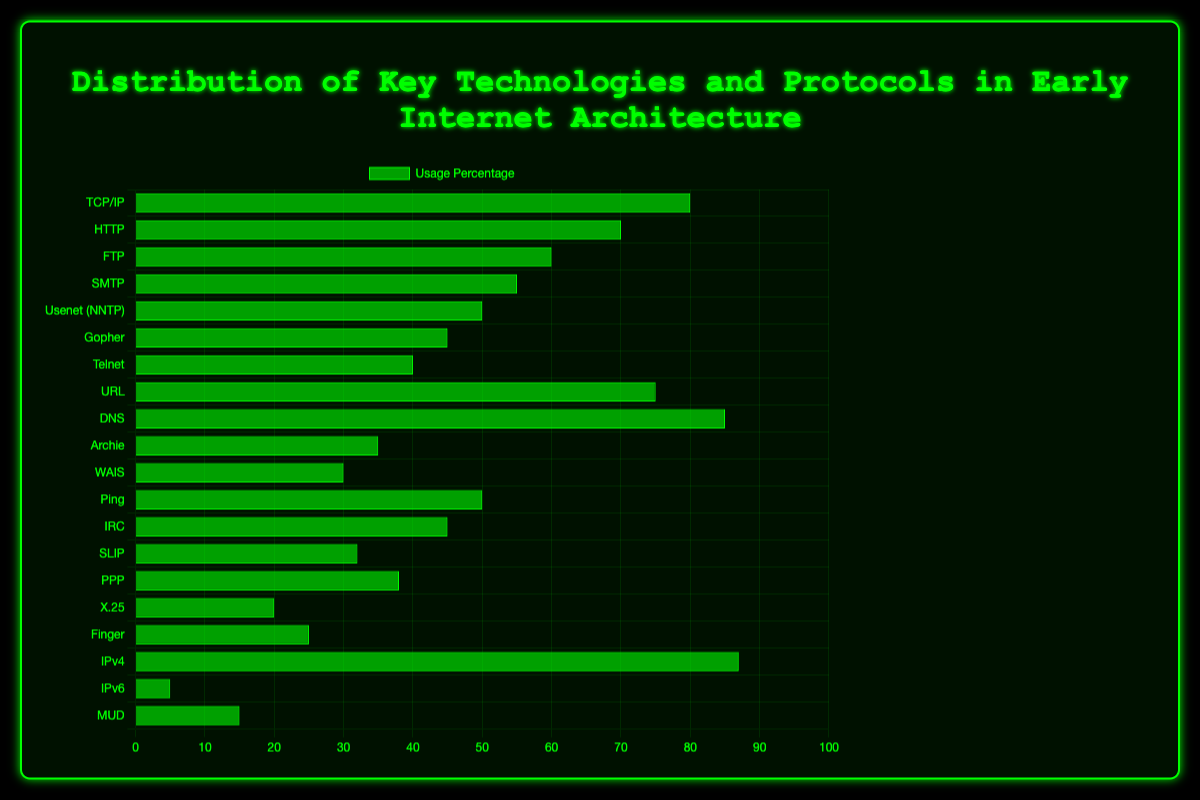Which technology has the highest usage percentage? The bar with the highest length on the y-axis represents the technology with the highest usage percentage. Here, it is "IPv4" with 87%.
Answer: IPv4 Which technology has the lowest usage percentage? The bar with the smallest length on the y-axis represents the technology with the lowest usage percentage. Here, it is "IPv6" with 5%.
Answer: IPv6 What is the difference in usage percentage between DNS and HTTP? DNS has a usage percentage of 85, and HTTP has a usage percentage of 70. The difference is 85 - 70 = 15.
Answer: 15 Which technologies have a usage percentage greater than 50%? The technologies with their bars extending beyond the 50% mark on the x-axis are IPv4 (87%), DNS (85%), TCP/IP (80%), URL (75%), HTTP (70%), and FTP (60%).
Answer: IPv4, DNS, TCP/IP, URL, HTTP, FTP What is the average usage percentage of TCP/IP, HTTP, and FTP? The usage percentages for TCP/IP, HTTP, and FTP are 80, 70, and 60, respectively. The average is (80 + 70 + 60) / 3 = 70.
Answer: 70 Which technology has a usage percentage of 35%? The bar corresponding to a 35% usage percentage on the x-axis is labeled "Archie".
Answer: Archie Are there more technologies with a usage percentage above 50% or below 50%? Count the technologies with their bars extending beyond the 50% mark and those that do not. Six technologies are above 50%, and fourteen are below 50%.
Answer: Below 50% What is the median usage percentage? To find the median, list the usage percentages in order: 5, 15, 20, 25, 30, 32, 35, 38, 40, 45, 45, 50, 50, 55, 60, 70, 75, 80, 85, 87. The median is the average of the 10th and 11th values: (45 + 45) / 2 = 45.
Answer: 45 What is the sum of usage percentages for Gopher and Telnet? Gopher has a usage percentage of 45, and Telnet has 40. The sum is 45 + 40 = 85.
Answer: 85 